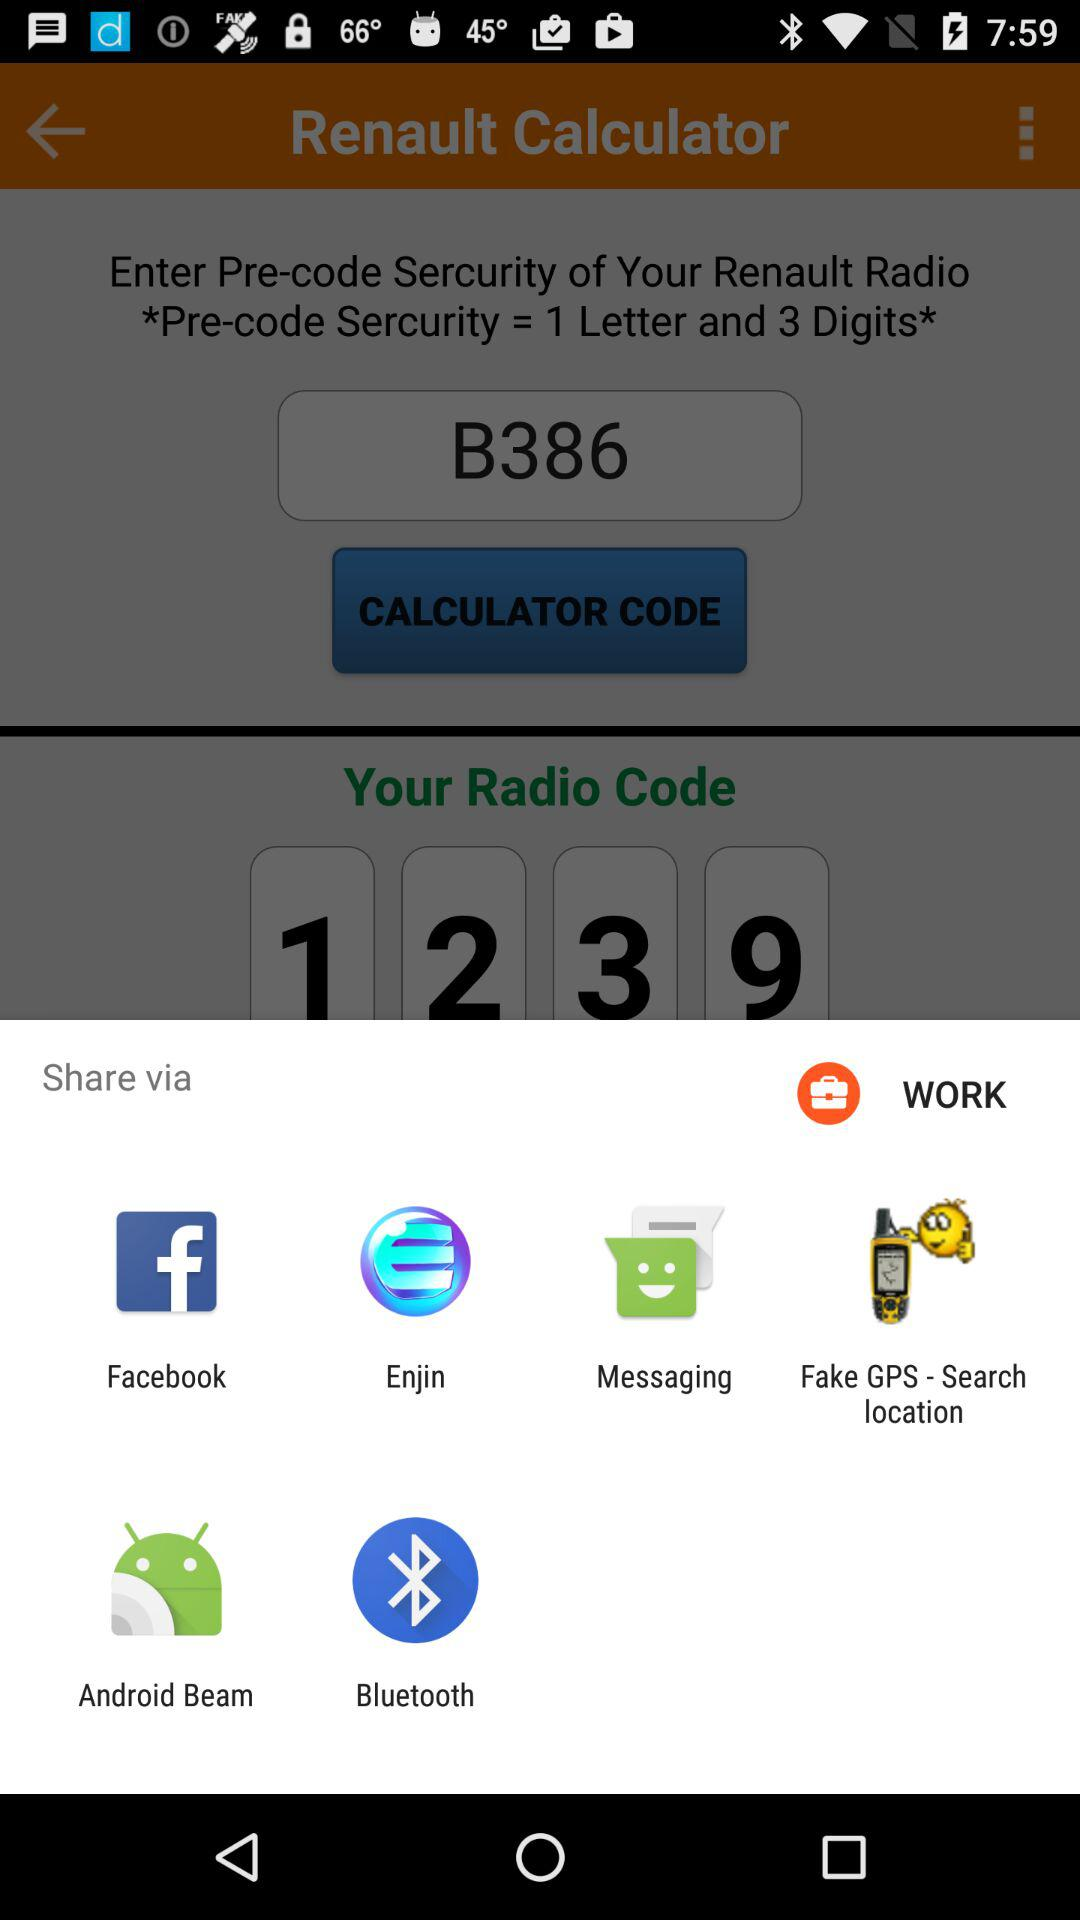How many digits are there in the radio code?
Answer the question using a single word or phrase. 4 